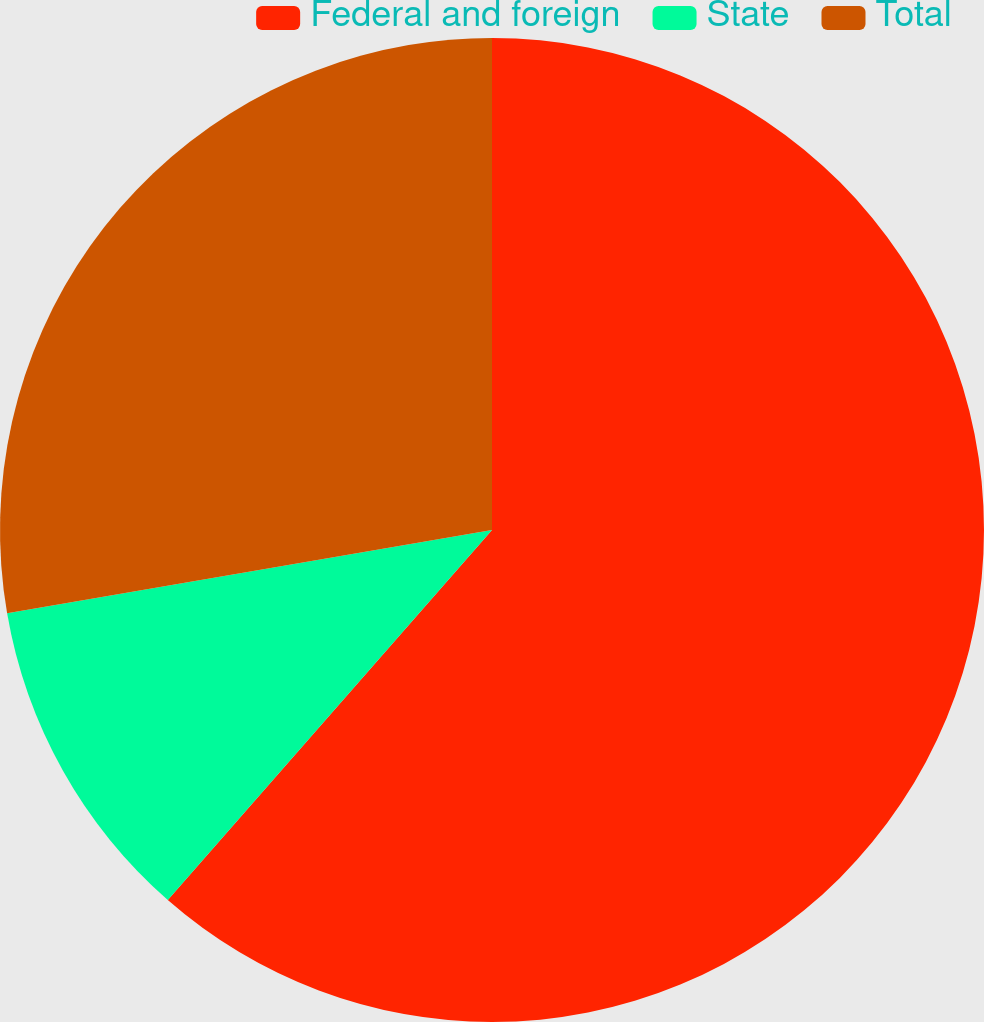Convert chart to OTSL. <chart><loc_0><loc_0><loc_500><loc_500><pie_chart><fcel>Federal and foreign<fcel>State<fcel>Total<nl><fcel>61.45%<fcel>10.84%<fcel>27.71%<nl></chart> 